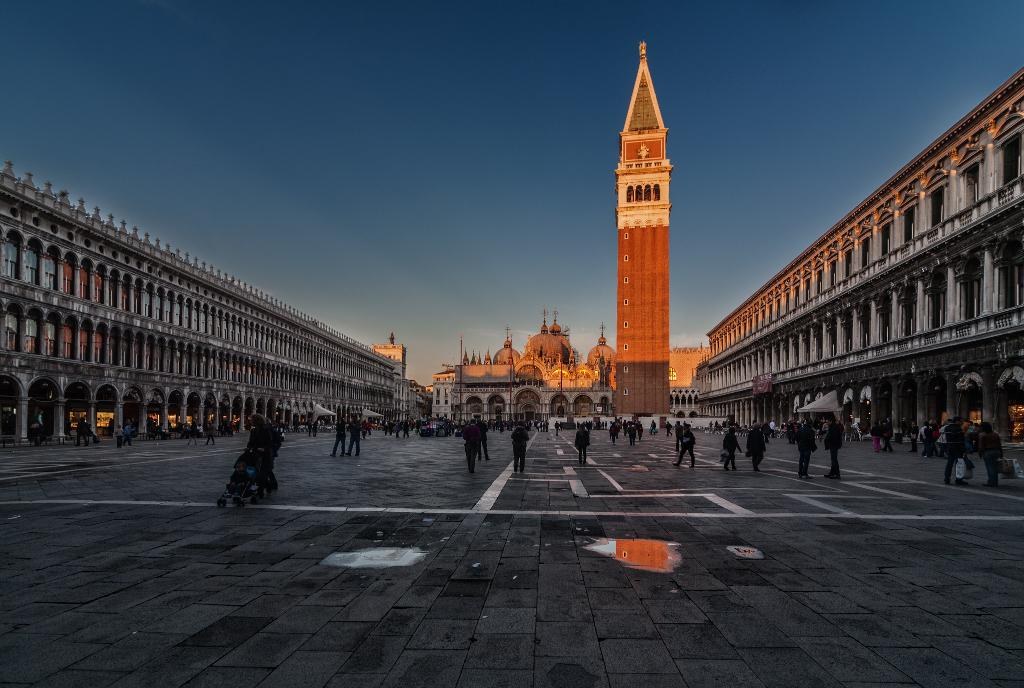What are the people in the image doing? The people in the image are walking. What structures can be seen in the image? There are buildings in the image. What is visible at the top of the image? The sky is visible at the top of the image. What color is the sky in the image? The sky is blue in the image. Can you give me an example of a bear in the image? There is no bear present in the image. What idea does the image convey about the people walking? The image does not convey any specific idea about the people walking; it simply shows them walking. 